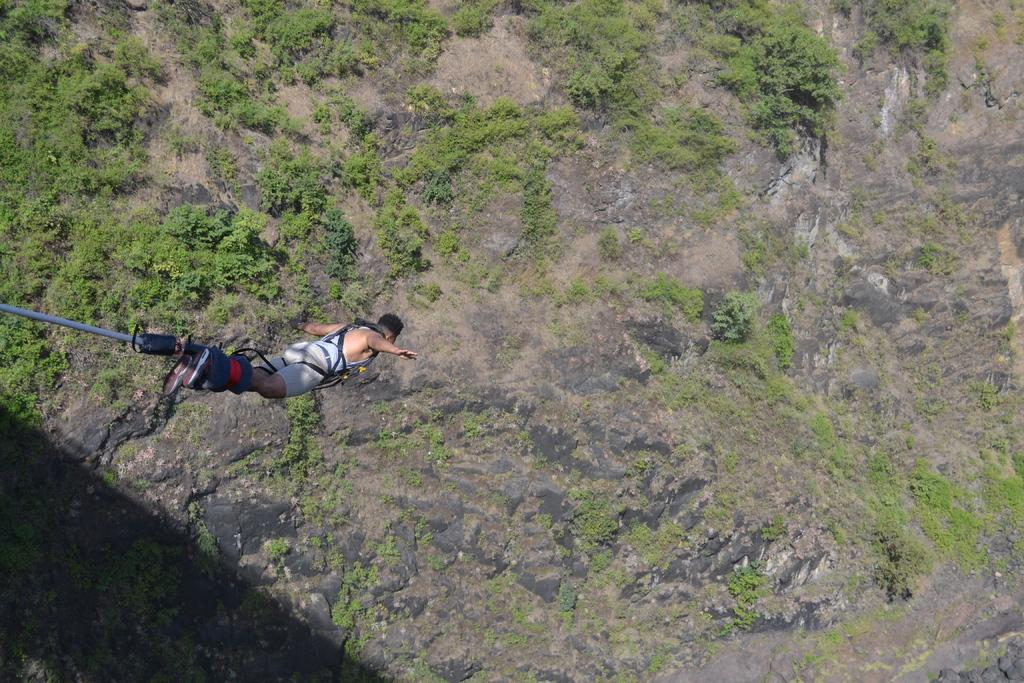What is the main subject in the foreground of the image? There is a person in the foreground of the image. What is the person doing in the image? The person is jumping in the air. What can be seen in the background of the image? There are trees and mountains in the background of the image. When was the image taken? The image is taken during the day. From what perspective is the image taken? The image is taken from a sky view. What type of receipt can be seen in the person's hand in the image? There is no receipt visible in the person's hand in the image. What kind of lunch is the person eating while jumping in the air? The image does not show the person eating lunch, and there is no food visible. 